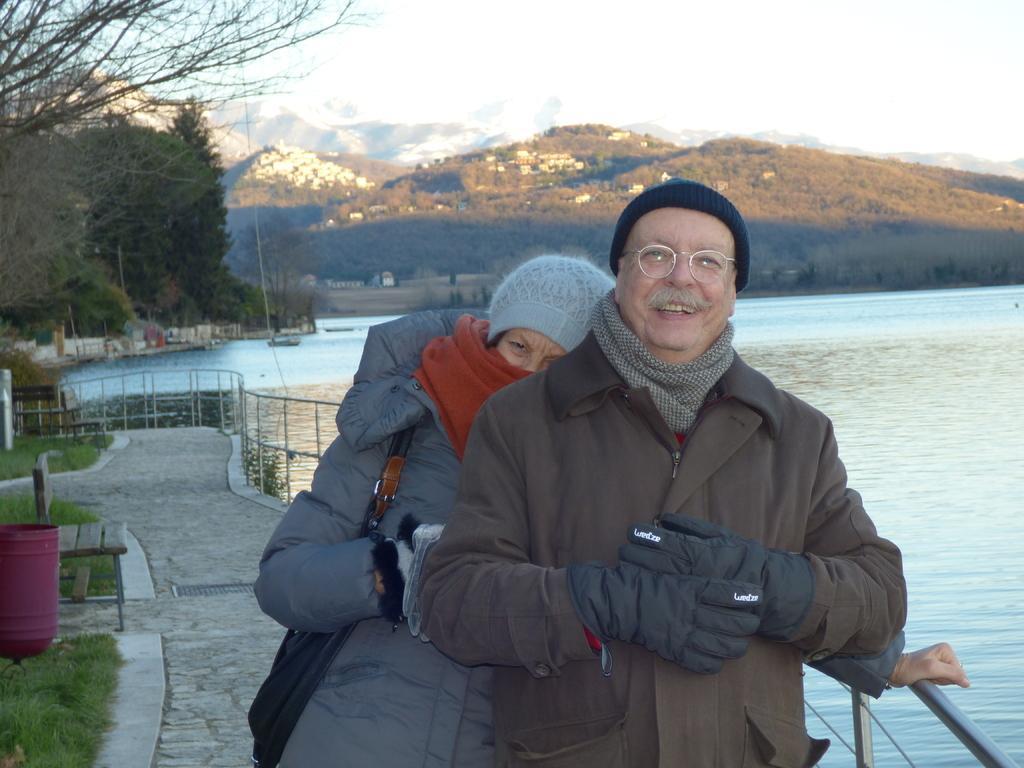Could you give a brief overview of what you see in this image? In the picture I can see a man and a woman are standing together. In the background I can see the water, trees, fence, the grass, bench, mountains and the sky. 